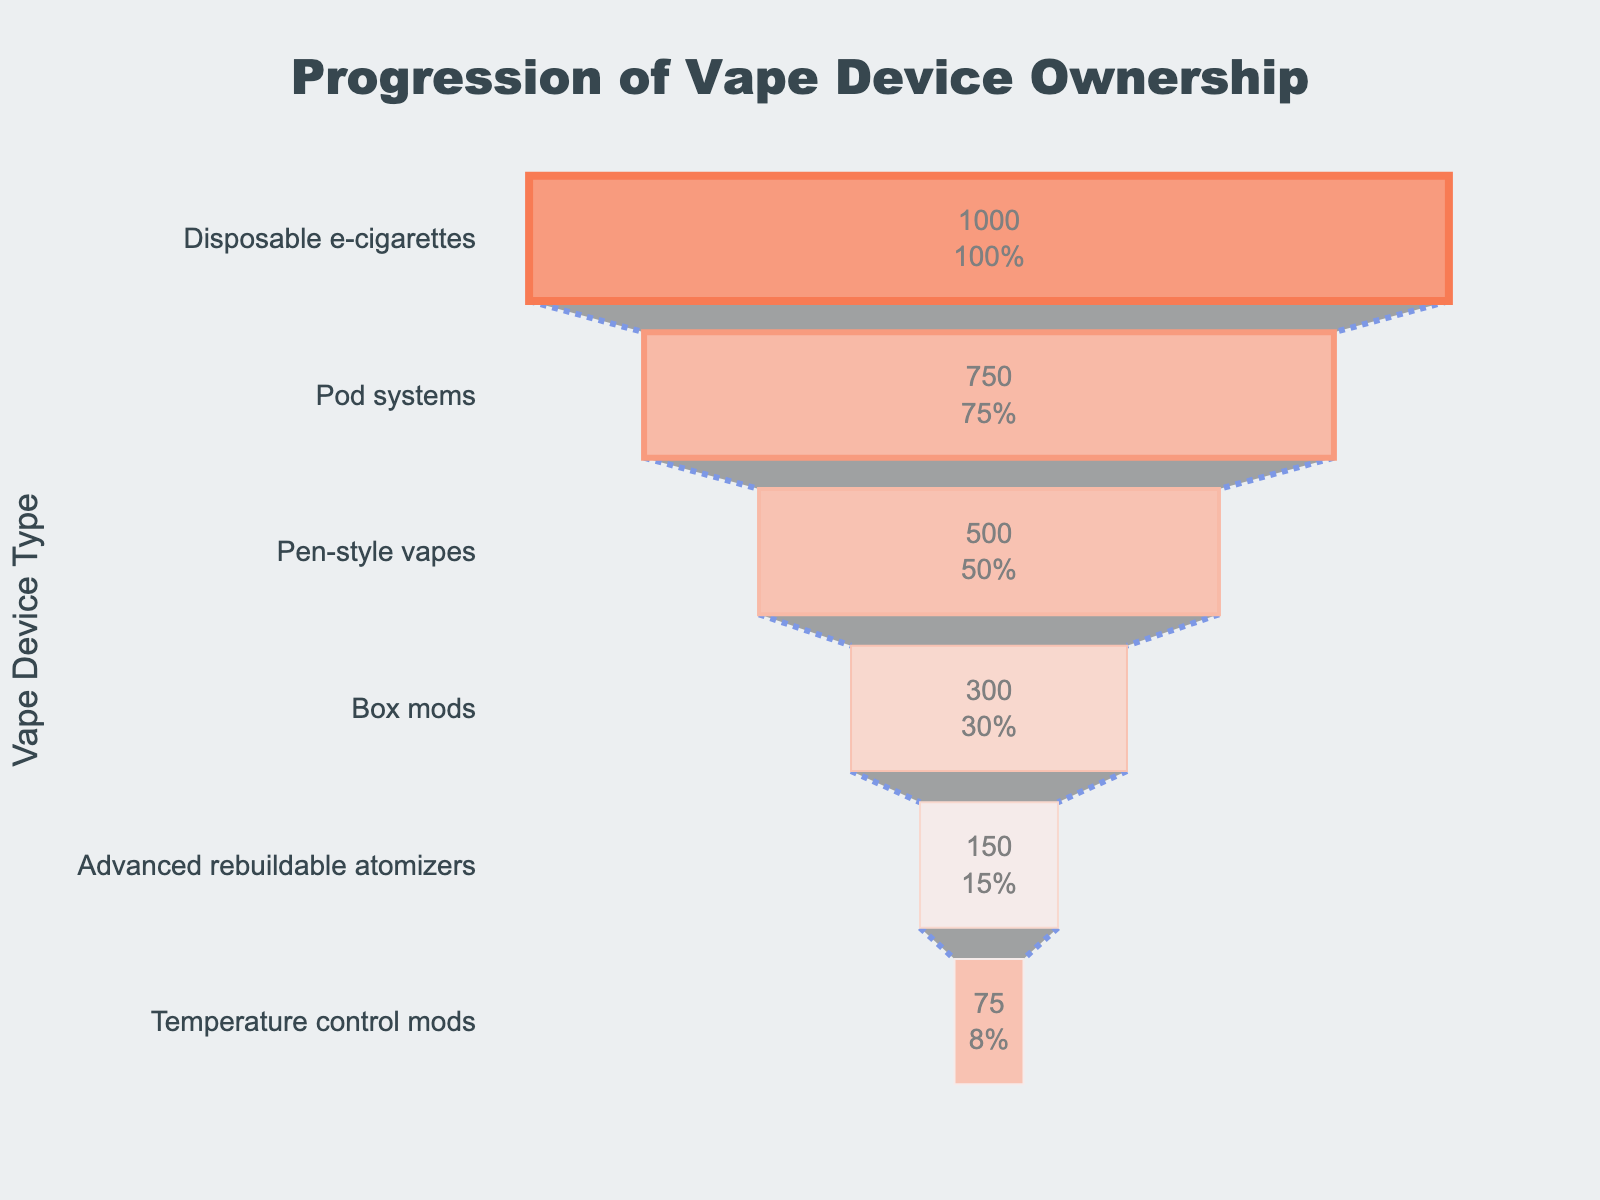What is the title of the funnel chart? The title is at the top center of the chart in large, bold text. It indicates the funnel chart's purpose.
Answer: "Progression of Vape Device Ownership" Which stage has the most users? The stage with the largest number of users is at the widest part of the funnel. It has the highest value for the 'Users' attribute.
Answer: Disposable e-cigarettes What percentage of users transition from Pod systems to Pen-style vapes? To find the percentage, divide the number of users for Pen-style vapes by the number of users for Pod systems, multiplying the result by 100.
Answer: 66.67% How many users progress from Disposable e-cigarettes to Box mods? Subtract the number of users in the Box mods stage from the Disposable e-cigarettes stage.
Answer: 700 users What is the total number of users across all stages? Sum up the number of users for all vape device stages: 1000 + 750 + 500 + 300 + 150 + 75
Answer: 2775 users How does the number of Temperature control mods users compare to Advanced rebuildable atomizers users? Look at the number of users for each stage and identify which number is higher.
Answer: Temperature control mods users are fewer than Advanced rebuildable atomizers users Which stage has the steepest drop in user numbers compared to the previous stage? Look for the stage where the difference between the number of users from its preceding stage is the largest.
Answer: Disposable e-cigarettes to Pod systems What is the difference in user numbers between the Box mods and Pen-style vapes stages? Subtract the number of users in the Box mods stage from the Pen-style vapes stage.
Answer: 200 users Which two stages combined account for the smallest number of total users? Add up the user numbers for different stage pairs and find the smallest sum.
Answer: Advanced rebuildable atomizers and Temperature control mods 